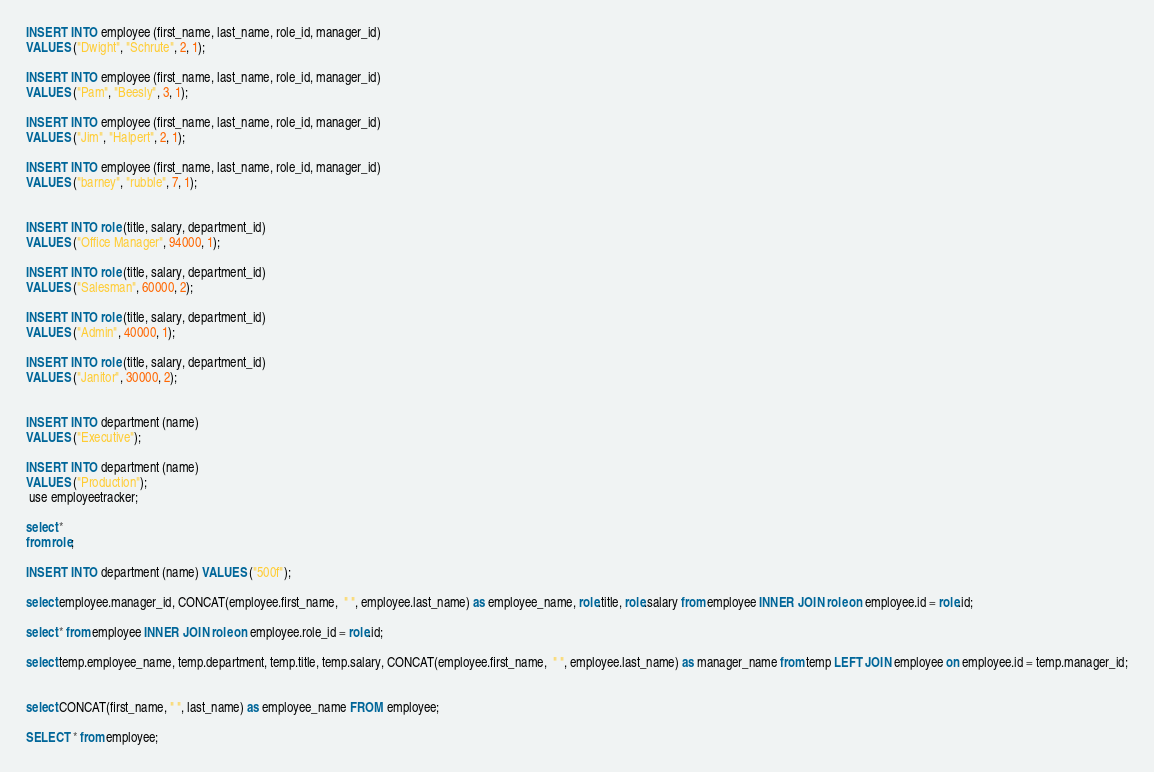<code> <loc_0><loc_0><loc_500><loc_500><_SQL_>INSERT INTO employee (first_name, last_name, role_id, manager_id)
VALUES ("Dwight", "Schrute", 2, 1);

INSERT INTO employee (first_name, last_name, role_id, manager_id)
VALUES ("Pam", "Beesly", 3, 1);

INSERT INTO employee (first_name, last_name, role_id, manager_id)
VALUES ("Jim", "Halpert", 2, 1);

INSERT INTO employee (first_name, last_name, role_id, manager_id)
VALUES ("barney", "rubble", 7, 1);


INSERT INTO role (title, salary, department_id)
VALUES ("Office Manager", 94000, 1);

INSERT INTO role (title, salary, department_id)
VALUES ("Salesman", 60000, 2);

INSERT INTO role (title, salary, department_id)
VALUES ("Admin", 40000, 1);

INSERT INTO role (title, salary, department_id)
VALUES ("Janitor", 30000, 2);


INSERT INTO department (name)
VALUES ("Executive");

INSERT INTO department (name)
VALUES ("Production");
 use employeetracker;

select *
from role;

INSERT INTO department (name) VALUES ("500f");

select employee.manager_id, CONCAT(employee.first_name,  " ", employee.last_name) as employee_name, role.title, role.salary from employee INNER JOIN role on employee.id = role.id;

select * from employee INNER JOIN role on employee.role_id = role.id;

select temp.employee_name, temp.department, temp.title, temp.salary, CONCAT(employee.first_name,  " ", employee.last_name) as manager_name from temp LEFT JOIN employee on employee.id = temp.manager_id;


select CONCAT(first_name, " ", last_name) as employee_name FROM employee;

SELECT * from employee;
</code> 